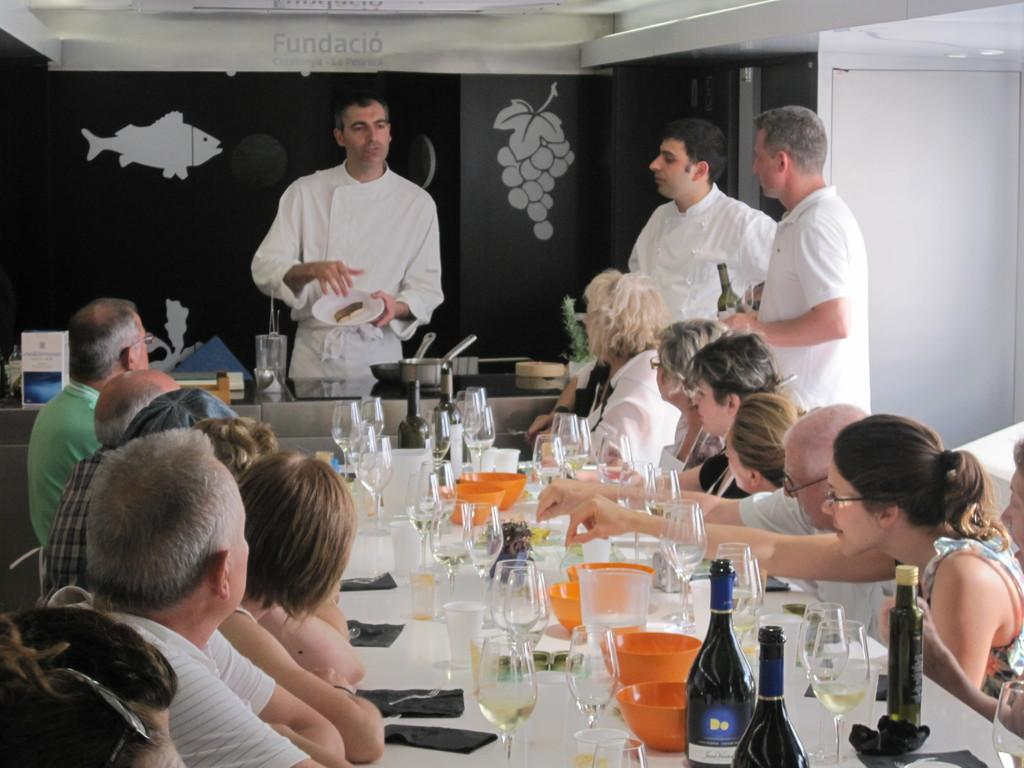What are the people in the image doing? Some people are sitting and some are standing in the image. What can be seen on the table in the image? There is a wine glass, a bottle, and a bowl on the table. How many objects are on the table in the image? There are three objects on the table: a wine glass, a bottle, and a bowl. What type of brush is being used for arithmetic in the image? There is no brush or arithmetic activity present in the image. 